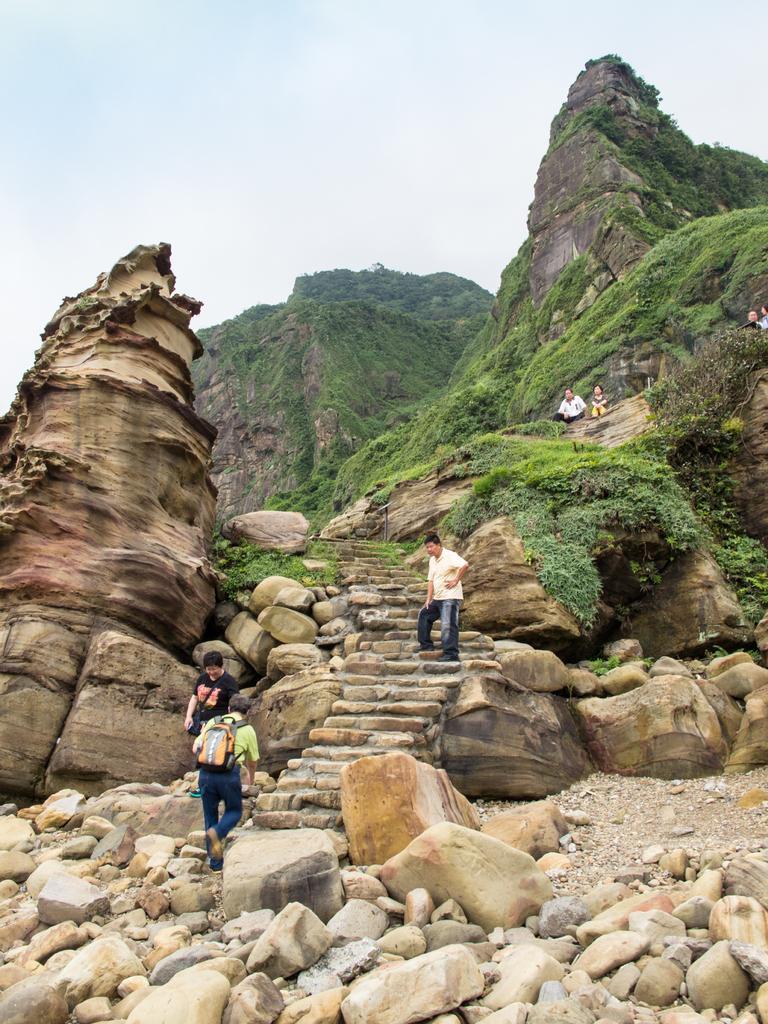How would you summarize this image in a sentence or two? There are huge rocks and few people are walking around the rocks and two of them were sitting upon the hill on the right side and one person is standing on the steps, in the background there is a sky. 